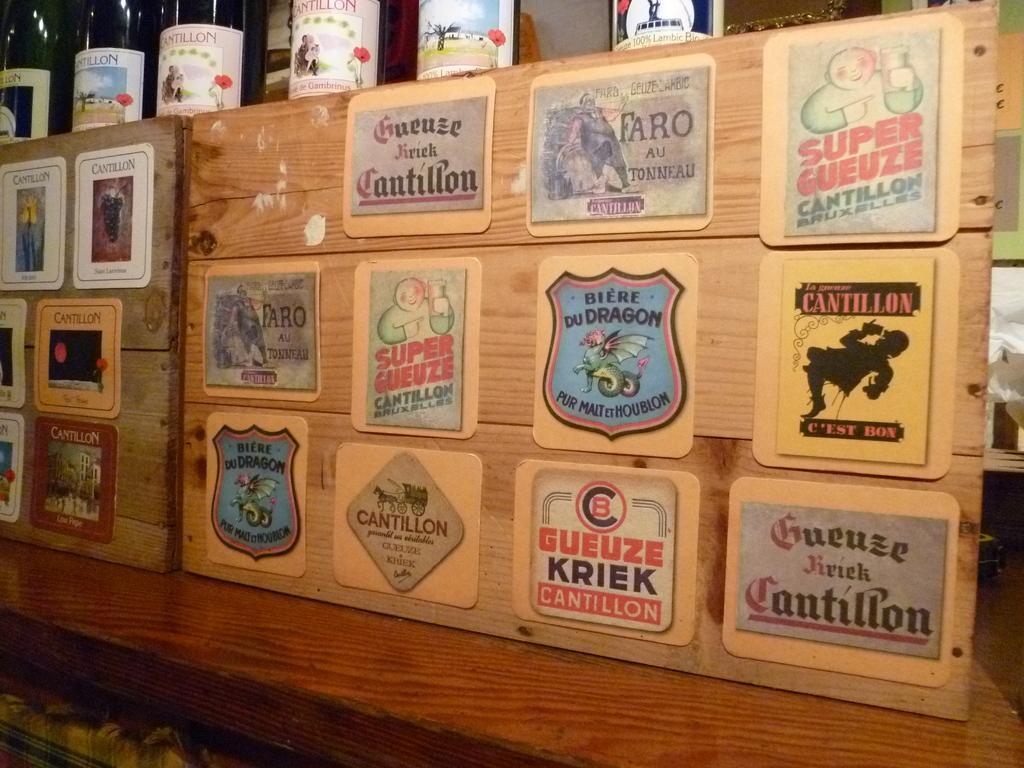Could you give a brief overview of what you see in this image? In this picture we can see some boards pasted on wood, there are some bottles at the top of the picture. 